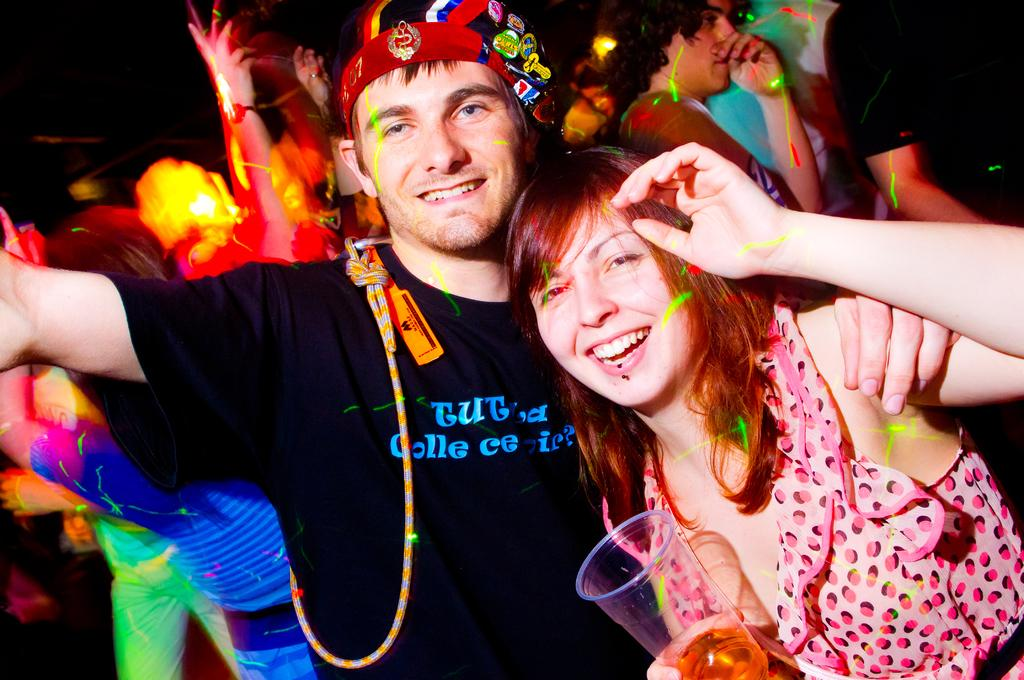What is the composition of the group in the image? There is a group of people in the image, including a woman and a man. What are the expressions on the faces of the woman and the man? The woman and the man are seeing and smiling in the image. What is the woman holding in the image? The woman is holding a glass with liquid in the image. What type of linen is being used to clean the vest in the image? There is no linen or vest present in the image. What tool is the man using to tighten the wrench in the image? There is no wrench or tool present in the image. 